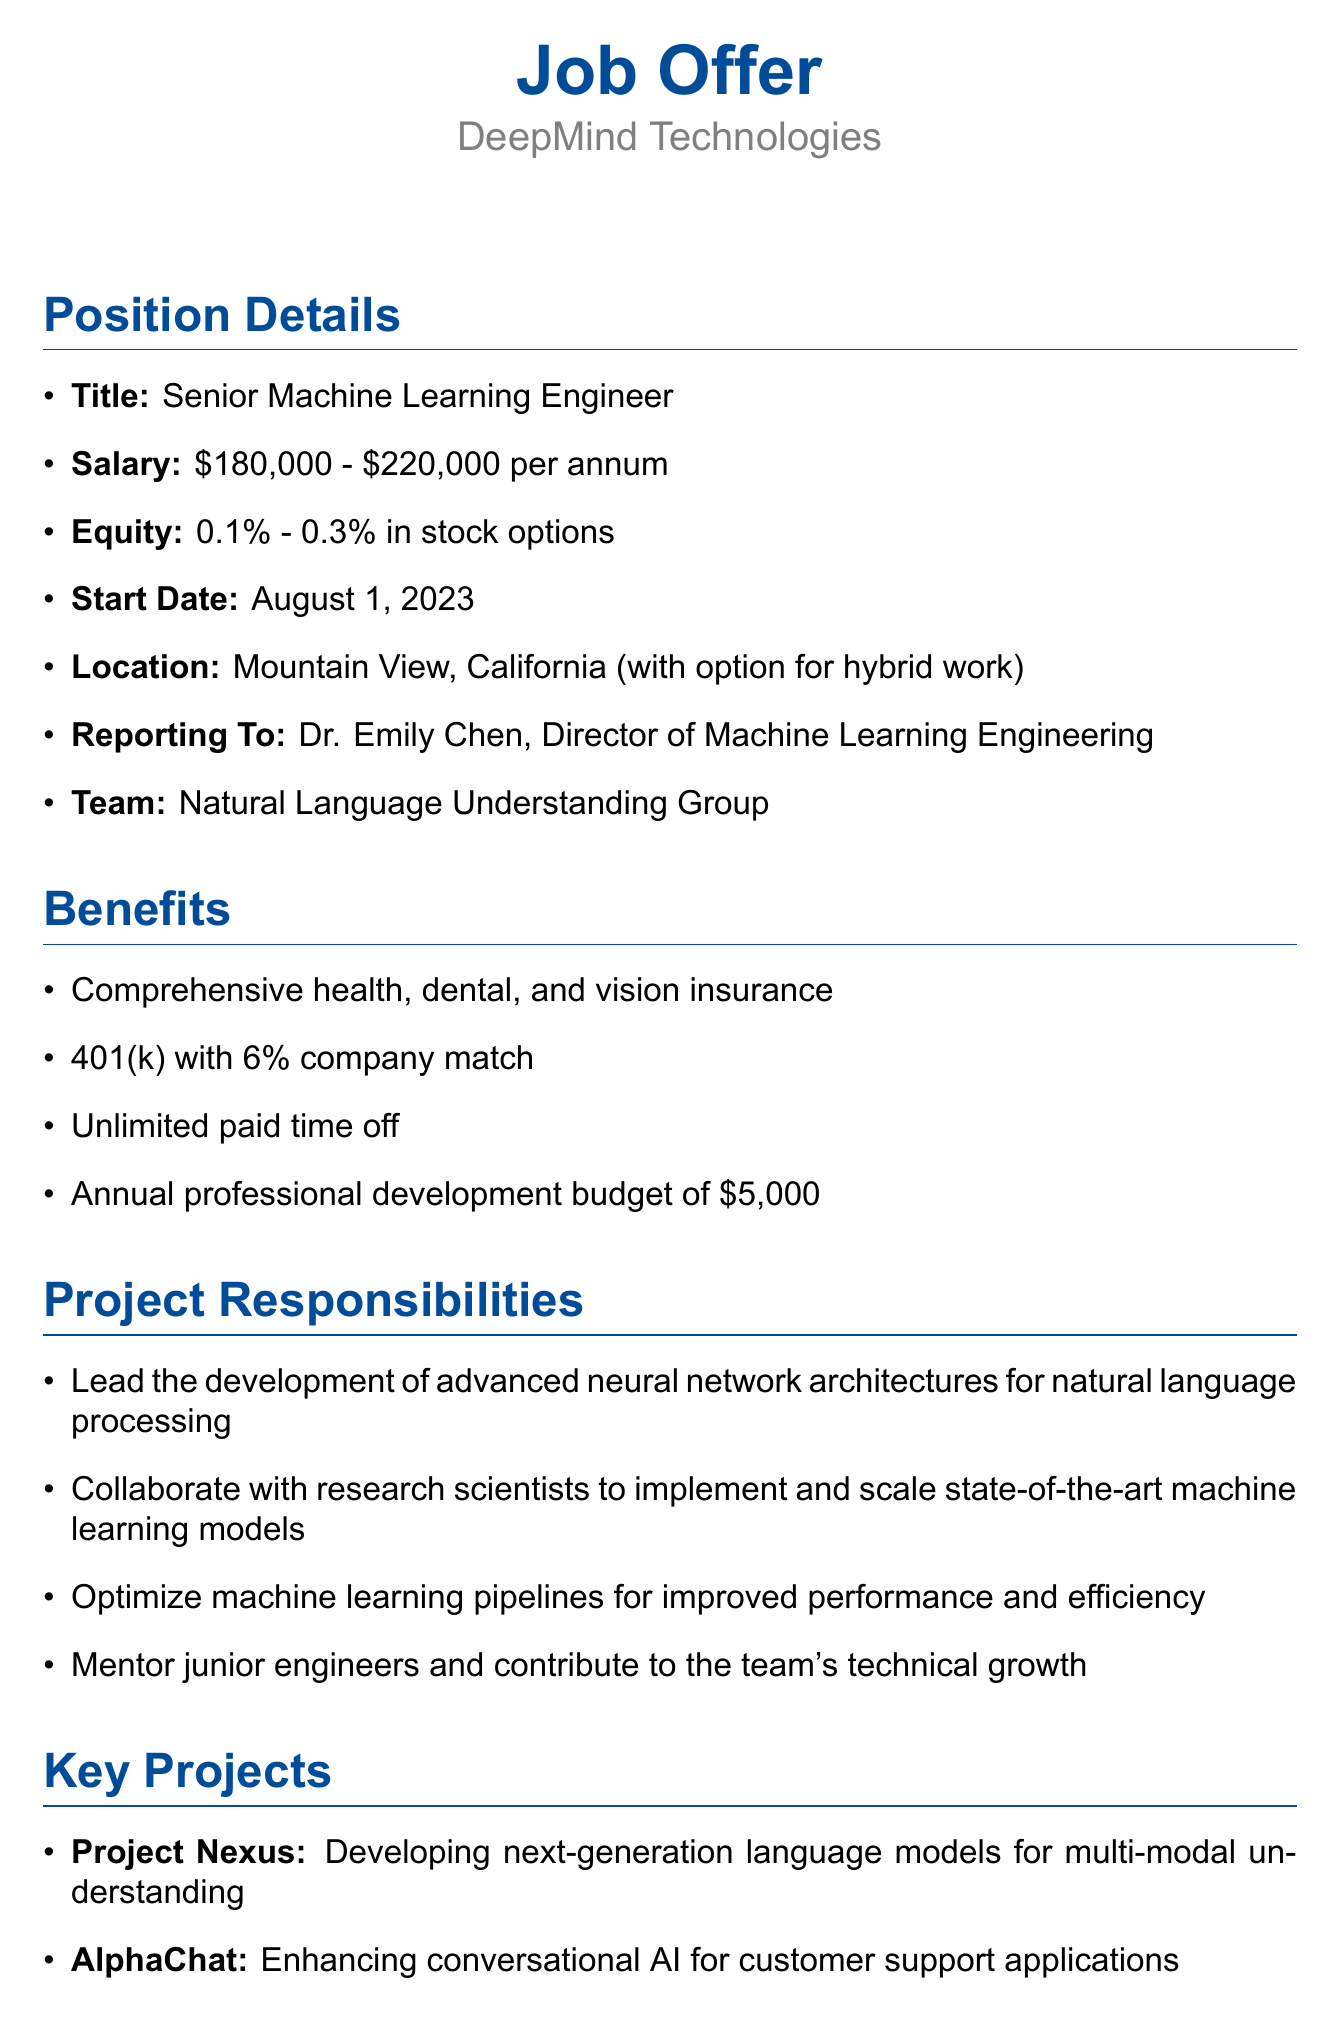What is the company name? The company name is specified at the beginning of the document as the organization offering the position.
Answer: DeepMind Technologies What is the salary range for the position? The salary range is listed under the position details section and indicates the compensation offered.
Answer: $180,000 - $220,000 per annum Who will the new hire report to? The reporting structure is mentioned in the position details, outlining the direct superior of the new hire.
Answer: Dr. Emily Chen What are the required skills for the Senior Machine Learning Engineer position? The skills required are compiled in a specific section of the document dedicated to qualifications for the job.
Answer: Expert-level proficiency in Python and TensorFlow What is one of the key projects mentioned in the offer? The key projects section provides insights into significant initiatives that the new hire will be involved in.
Answer: Project Nexus: Developing next-generation language models for multi-modal understanding How much is the annual professional development budget? This information is found in the benefits section, detailing additional support for the employee's growth.
Answer: $5,000 What benefit allows for flexible vacation time? The benefits section includes this feature as part of employee support, signaling a work-life balance initiative.
Answer: Unlimited paid time off What is the starting date for this position? The start date is outlined in the position details, indicating when the hired individual is expected to begin work.
Answer: August 1, 2023 